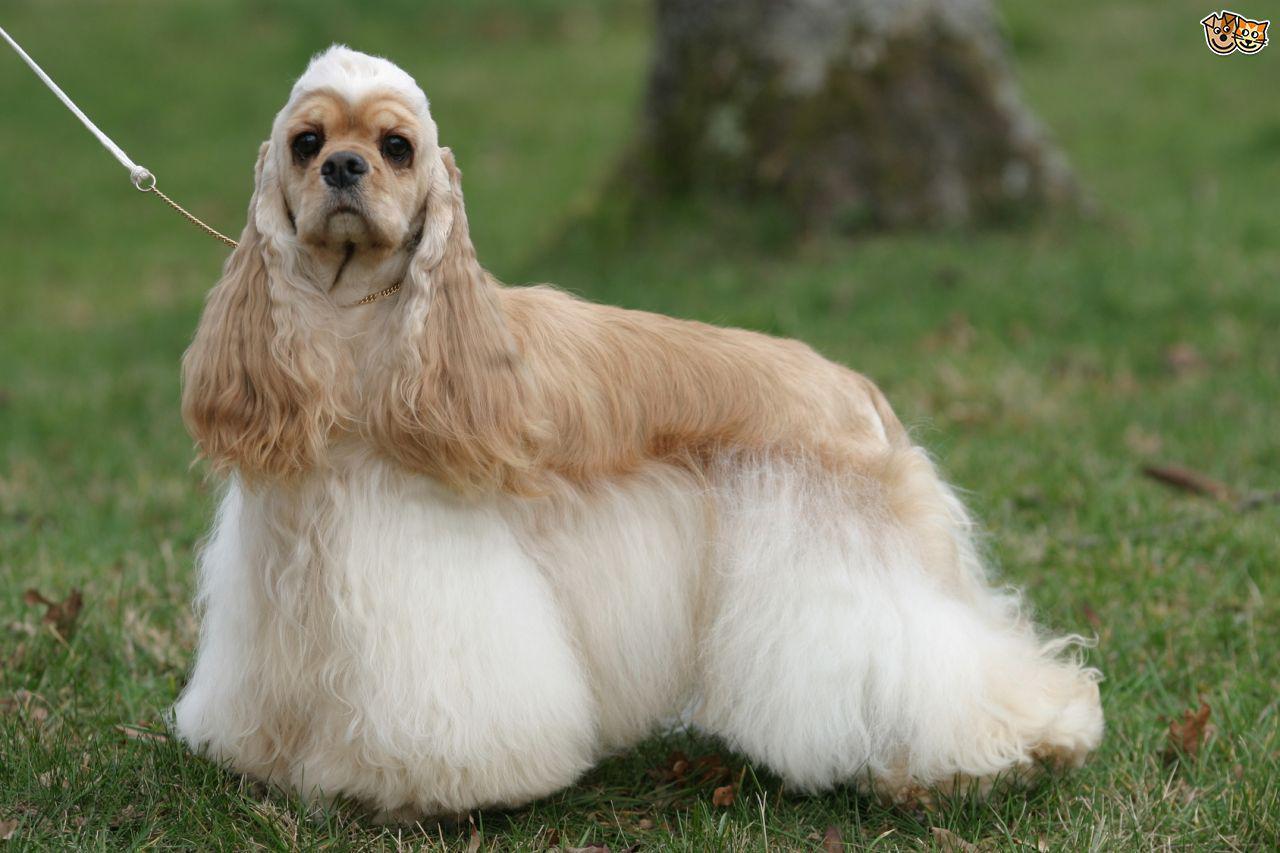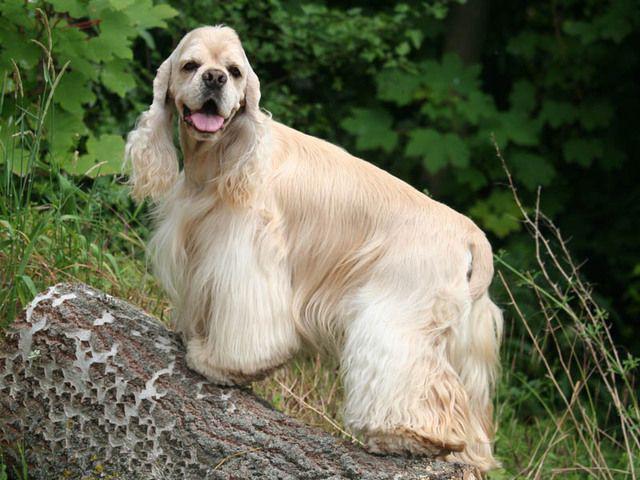The first image is the image on the left, the second image is the image on the right. Considering the images on both sides, is "Right image shows a solid colored golden spaniel standing in profile on grass." valid? Answer yes or no. No. The first image is the image on the left, the second image is the image on the right. Assess this claim about the two images: "There are non-flowering plants behind a dog.". Correct or not? Answer yes or no. Yes. 